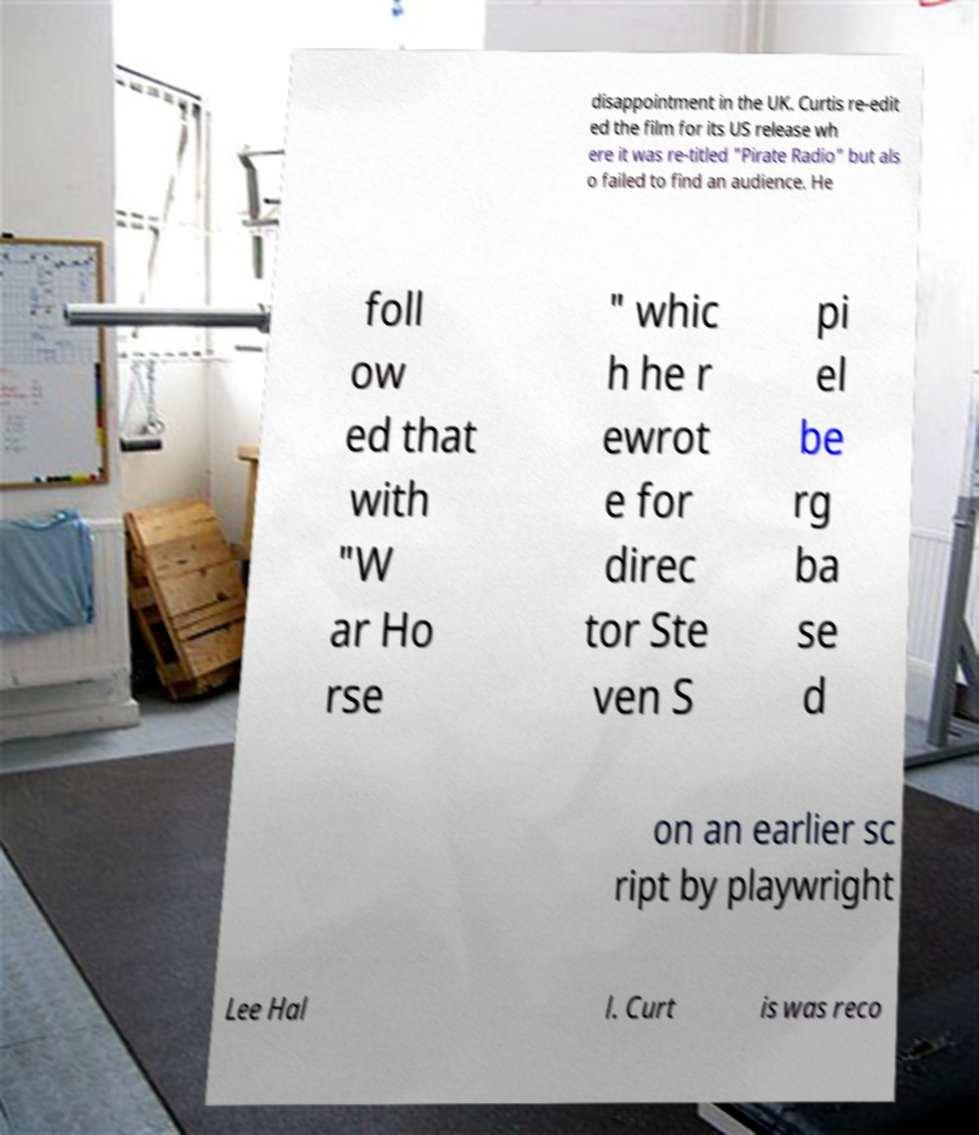What messages or text are displayed in this image? I need them in a readable, typed format. disappointment in the UK. Curtis re-edit ed the film for its US release wh ere it was re-titled "Pirate Radio" but als o failed to find an audience. He foll ow ed that with "W ar Ho rse " whic h he r ewrot e for direc tor Ste ven S pi el be rg ba se d on an earlier sc ript by playwright Lee Hal l. Curt is was reco 